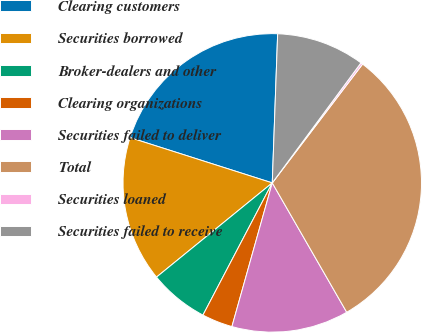<chart> <loc_0><loc_0><loc_500><loc_500><pie_chart><fcel>Clearing customers<fcel>Securities borrowed<fcel>Broker-dealers and other<fcel>Clearing organizations<fcel>Securities failed to deliver<fcel>Total<fcel>Securities loaned<fcel>Securities failed to receive<nl><fcel>20.67%<fcel>15.78%<fcel>6.44%<fcel>3.33%<fcel>12.67%<fcel>31.34%<fcel>0.22%<fcel>9.55%<nl></chart> 